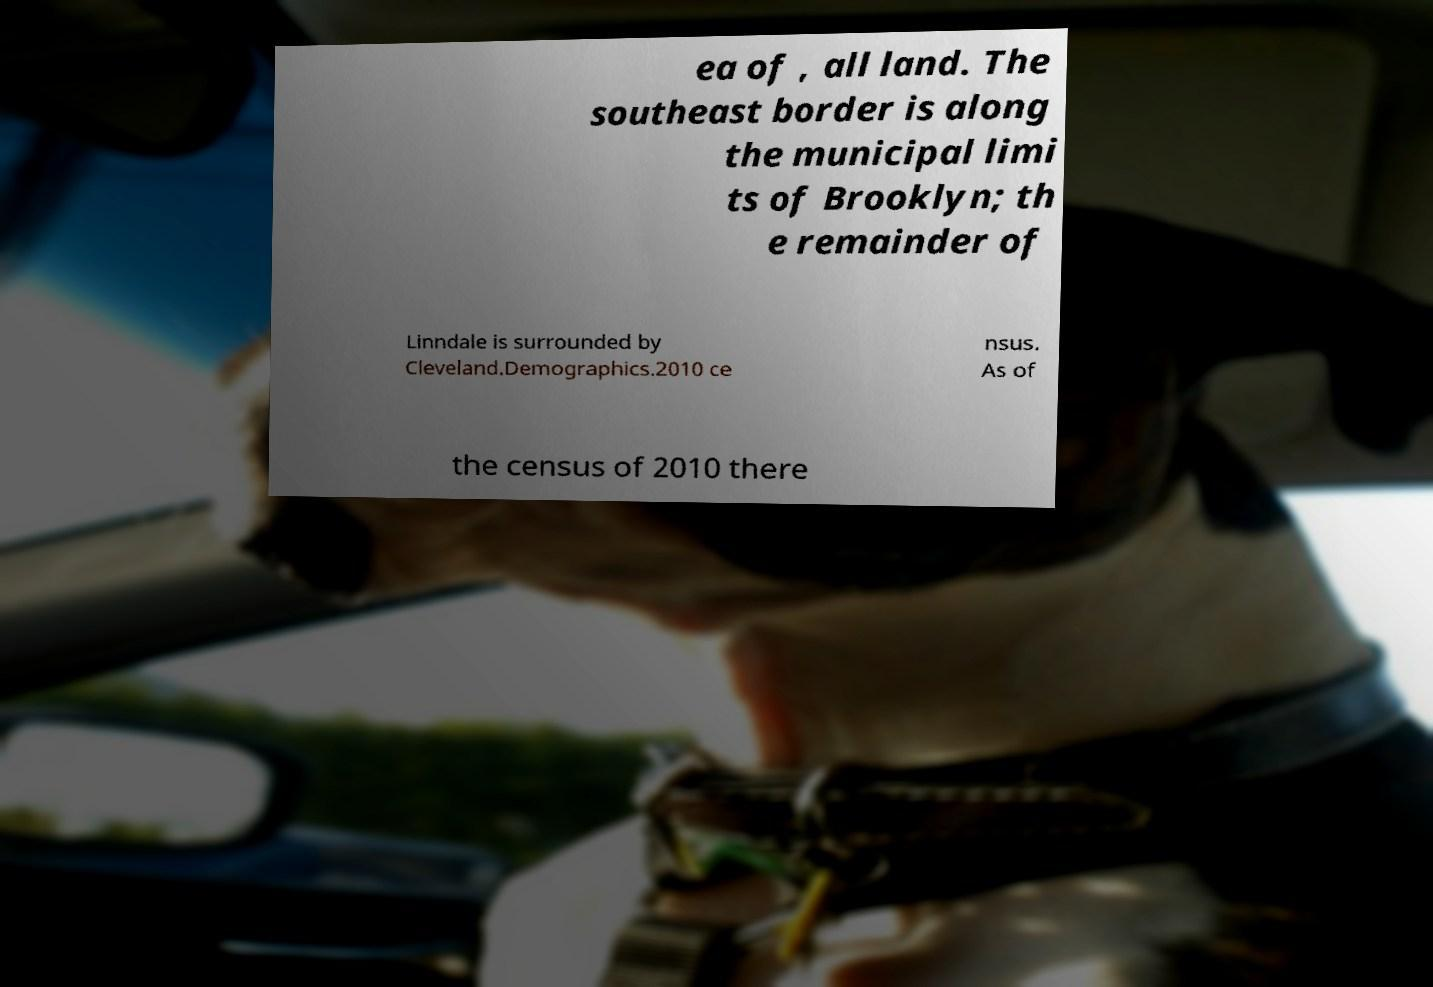Please identify and transcribe the text found in this image. ea of , all land. The southeast border is along the municipal limi ts of Brooklyn; th e remainder of Linndale is surrounded by Cleveland.Demographics.2010 ce nsus. As of the census of 2010 there 